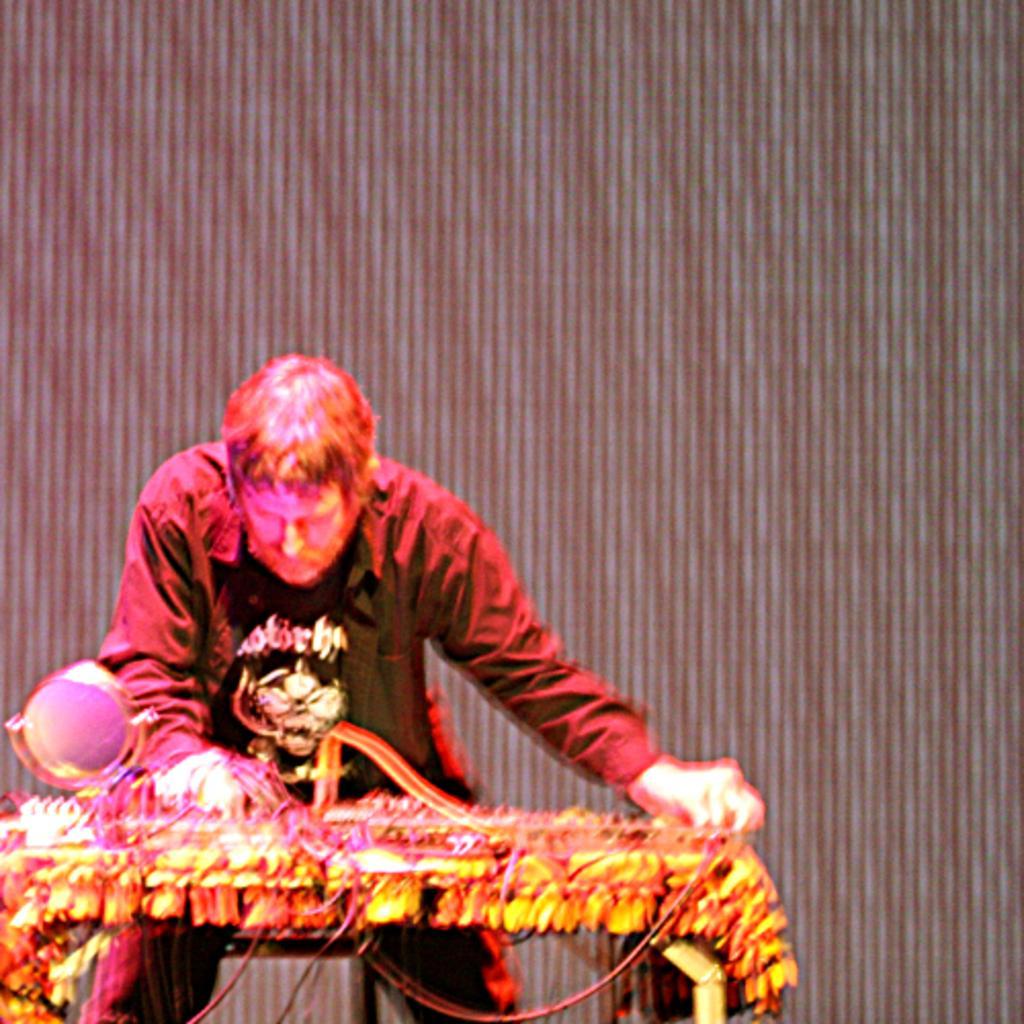How would you summarize this image in a sentence or two? In this image we can see one person, we can see a table and a few objects on it, behind we can see the curtain. 